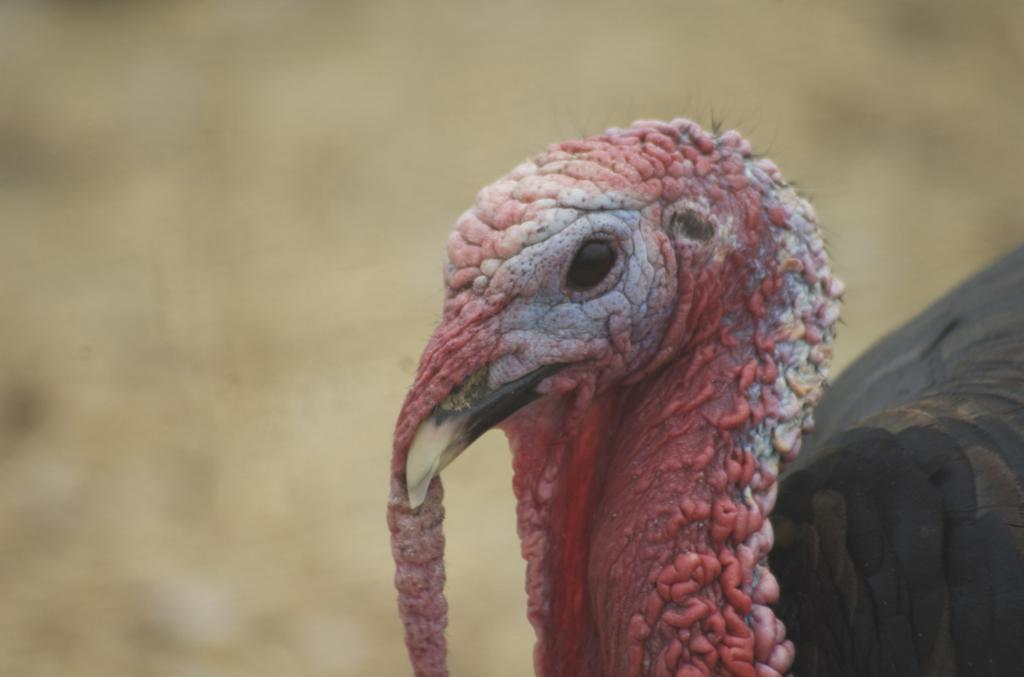What type of animal is in the image? There is a bird in the image. Can you describe the bird's appearance? The bird has black, brown, red, and white colors. What can be seen in the background of the image? There is a blurred, cream-colored background in the image. What type of skirt is the bird wearing in the image? Birds do not wear clothing, so there is no skirt present in the image. Is there a church visible in the image? There is no mention of a church in the provided facts, and therefore it cannot be determined if one is present in the image. 